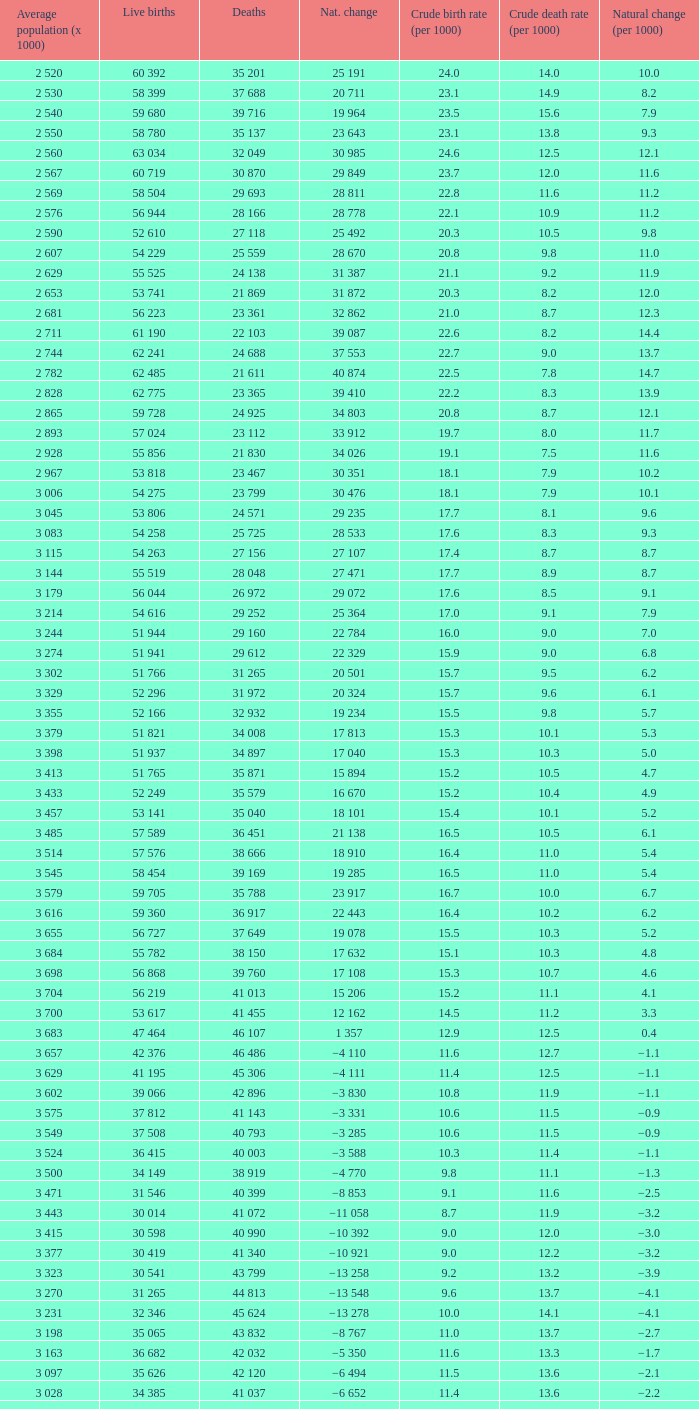Parse the full table. {'header': ['Average population (x 1000)', 'Live births', 'Deaths', 'Nat. change', 'Crude birth rate (per 1000)', 'Crude death rate (per 1000)', 'Natural change (per 1000)'], 'rows': [['2 520', '60 392', '35 201', '25 191', '24.0', '14.0', '10.0'], ['2 530', '58 399', '37 688', '20 711', '23.1', '14.9', '8.2'], ['2 540', '59 680', '39 716', '19 964', '23.5', '15.6', '7.9'], ['2 550', '58 780', '35 137', '23 643', '23.1', '13.8', '9.3'], ['2 560', '63 034', '32 049', '30 985', '24.6', '12.5', '12.1'], ['2 567', '60 719', '30 870', '29 849', '23.7', '12.0', '11.6'], ['2 569', '58 504', '29 693', '28 811', '22.8', '11.6', '11.2'], ['2 576', '56 944', '28 166', '28 778', '22.1', '10.9', '11.2'], ['2 590', '52 610', '27 118', '25 492', '20.3', '10.5', '9.8'], ['2 607', '54 229', '25 559', '28 670', '20.8', '9.8', '11.0'], ['2 629', '55 525', '24 138', '31 387', '21.1', '9.2', '11.9'], ['2 653', '53 741', '21 869', '31 872', '20.3', '8.2', '12.0'], ['2 681', '56 223', '23 361', '32 862', '21.0', '8.7', '12.3'], ['2 711', '61 190', '22 103', '39 087', '22.6', '8.2', '14.4'], ['2 744', '62 241', '24 688', '37 553', '22.7', '9.0', '13.7'], ['2 782', '62 485', '21 611', '40 874', '22.5', '7.8', '14.7'], ['2 828', '62 775', '23 365', '39 410', '22.2', '8.3', '13.9'], ['2 865', '59 728', '24 925', '34 803', '20.8', '8.7', '12.1'], ['2 893', '57 024', '23 112', '33 912', '19.7', '8.0', '11.7'], ['2 928', '55 856', '21 830', '34 026', '19.1', '7.5', '11.6'], ['2 967', '53 818', '23 467', '30 351', '18.1', '7.9', '10.2'], ['3 006', '54 275', '23 799', '30 476', '18.1', '7.9', '10.1'], ['3 045', '53 806', '24 571', '29 235', '17.7', '8.1', '9.6'], ['3 083', '54 258', '25 725', '28 533', '17.6', '8.3', '9.3'], ['3 115', '54 263', '27 156', '27 107', '17.4', '8.7', '8.7'], ['3 144', '55 519', '28 048', '27 471', '17.7', '8.9', '8.7'], ['3 179', '56 044', '26 972', '29 072', '17.6', '8.5', '9.1'], ['3 214', '54 616', '29 252', '25 364', '17.0', '9.1', '7.9'], ['3 244', '51 944', '29 160', '22 784', '16.0', '9.0', '7.0'], ['3 274', '51 941', '29 612', '22 329', '15.9', '9.0', '6.8'], ['3 302', '51 766', '31 265', '20 501', '15.7', '9.5', '6.2'], ['3 329', '52 296', '31 972', '20 324', '15.7', '9.6', '6.1'], ['3 355', '52 166', '32 932', '19 234', '15.5', '9.8', '5.7'], ['3 379', '51 821', '34 008', '17 813', '15.3', '10.1', '5.3'], ['3 398', '51 937', '34 897', '17 040', '15.3', '10.3', '5.0'], ['3 413', '51 765', '35 871', '15 894', '15.2', '10.5', '4.7'], ['3 433', '52 249', '35 579', '16 670', '15.2', '10.4', '4.9'], ['3 457', '53 141', '35 040', '18 101', '15.4', '10.1', '5.2'], ['3 485', '57 589', '36 451', '21 138', '16.5', '10.5', '6.1'], ['3 514', '57 576', '38 666', '18 910', '16.4', '11.0', '5.4'], ['3 545', '58 454', '39 169', '19 285', '16.5', '11.0', '5.4'], ['3 579', '59 705', '35 788', '23 917', '16.7', '10.0', '6.7'], ['3 616', '59 360', '36 917', '22 443', '16.4', '10.2', '6.2'], ['3 655', '56 727', '37 649', '19 078', '15.5', '10.3', '5.2'], ['3 684', '55 782', '38 150', '17 632', '15.1', '10.3', '4.8'], ['3 698', '56 868', '39 760', '17 108', '15.3', '10.7', '4.6'], ['3 704', '56 219', '41 013', '15 206', '15.2', '11.1', '4.1'], ['3 700', '53 617', '41 455', '12 162', '14.5', '11.2', '3.3'], ['3 683', '47 464', '46 107', '1 357', '12.9', '12.5', '0.4'], ['3 657', '42 376', '46 486', '−4 110', '11.6', '12.7', '−1.1'], ['3 629', '41 195', '45 306', '−4 111', '11.4', '12.5', '−1.1'], ['3 602', '39 066', '42 896', '−3 830', '10.8', '11.9', '−1.1'], ['3 575', '37 812', '41 143', '−3 331', '10.6', '11.5', '−0.9'], ['3 549', '37 508', '40 793', '−3 285', '10.6', '11.5', '−0.9'], ['3 524', '36 415', '40 003', '−3 588', '10.3', '11.4', '−1.1'], ['3 500', '34 149', '38 919', '−4 770', '9.8', '11.1', '−1.3'], ['3 471', '31 546', '40 399', '−8 853', '9.1', '11.6', '−2.5'], ['3 443', '30 014', '41 072', '−11 058', '8.7', '11.9', '−3.2'], ['3 415', '30 598', '40 990', '−10 392', '9.0', '12.0', '−3.0'], ['3 377', '30 419', '41 340', '−10 921', '9.0', '12.2', '−3.2'], ['3 323', '30 541', '43 799', '−13 258', '9.2', '13.2', '−3.9'], ['3 270', '31 265', '44 813', '−13 548', '9.6', '13.7', '−4.1'], ['3 231', '32 346', '45 624', '−13 278', '10.0', '14.1', '−4.1'], ['3 198', '35 065', '43 832', '−8 767', '11.0', '13.7', '−2.7'], ['3 163', '36 682', '42 032', '−5 350', '11.6', '13.3', '−1.7'], ['3 097', '35 626', '42 120', '−6 494', '11.5', '13.6', '−2.1'], ['3 028', '34 385', '41 037', '−6 652', '11.4', '13.6', '−2.2'], ['2 988', '30 459', '40 938', '−10 479', '10.2', '13.7', '−3.5']]} Which Live births have a Natural change (per 1000) of 12.0? 53 741. 